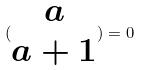<formula> <loc_0><loc_0><loc_500><loc_500>( \begin{matrix} a \\ a + 1 \end{matrix} ) = 0</formula> 